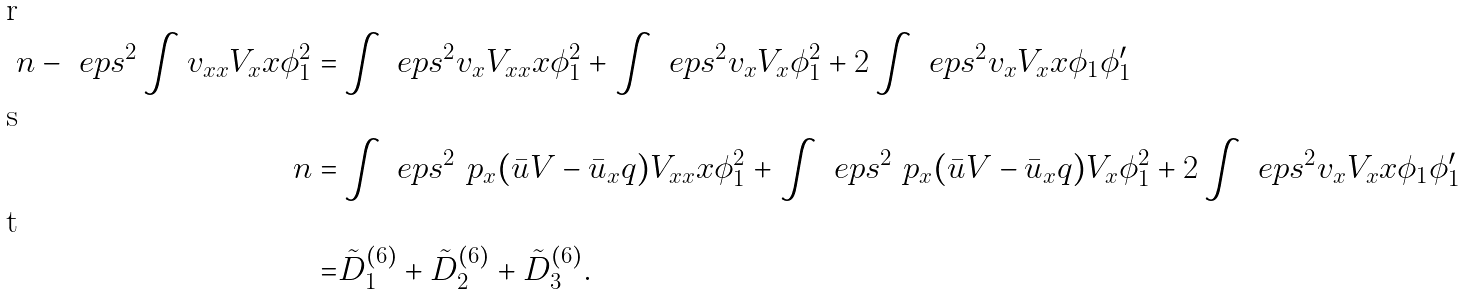<formula> <loc_0><loc_0><loc_500><loc_500>\ n - \ e p s ^ { 2 } \int v _ { x x } V _ { x } x \phi _ { 1 } ^ { 2 } = & \int \ e p s ^ { 2 } v _ { x } V _ { x x } x \phi _ { 1 } ^ { 2 } + \int \ e p s ^ { 2 } v _ { x } V _ { x } \phi _ { 1 } ^ { 2 } + 2 \int \ e p s ^ { 2 } v _ { x } V _ { x } x \phi _ { 1 } \phi _ { 1 } ^ { \prime } \\ \ n = & \int \ e p s ^ { 2 } \ p _ { x } ( \bar { u } V - \bar { u } _ { x } q ) V _ { x x } x \phi _ { 1 } ^ { 2 } + \int \ e p s ^ { 2 } \ p _ { x } ( \bar { u } V - \bar { u } _ { x } q ) V _ { x } \phi _ { 1 } ^ { 2 } + 2 \int \ e p s ^ { 2 } v _ { x } V _ { x } x \phi _ { 1 } \phi _ { 1 } ^ { \prime } \\ = & \tilde { D } ^ { ( 6 ) } _ { 1 } + \tilde { D } ^ { ( 6 ) } _ { 2 } + \tilde { D } ^ { ( 6 ) } _ { 3 } .</formula> 